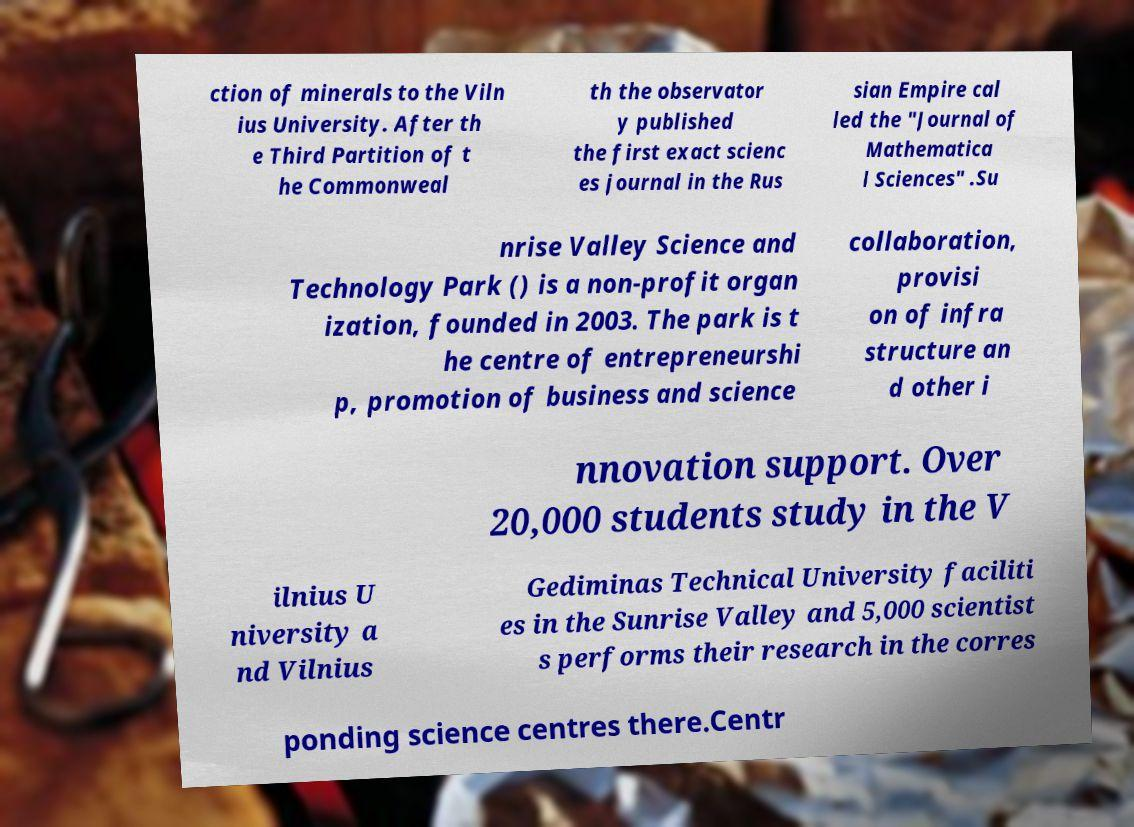I need the written content from this picture converted into text. Can you do that? ction of minerals to the Viln ius University. After th e Third Partition of t he Commonweal th the observator y published the first exact scienc es journal in the Rus sian Empire cal led the "Journal of Mathematica l Sciences" .Su nrise Valley Science and Technology Park () is a non-profit organ ization, founded in 2003. The park is t he centre of entrepreneurshi p, promotion of business and science collaboration, provisi on of infra structure an d other i nnovation support. Over 20,000 students study in the V ilnius U niversity a nd Vilnius Gediminas Technical University faciliti es in the Sunrise Valley and 5,000 scientist s performs their research in the corres ponding science centres there.Centr 